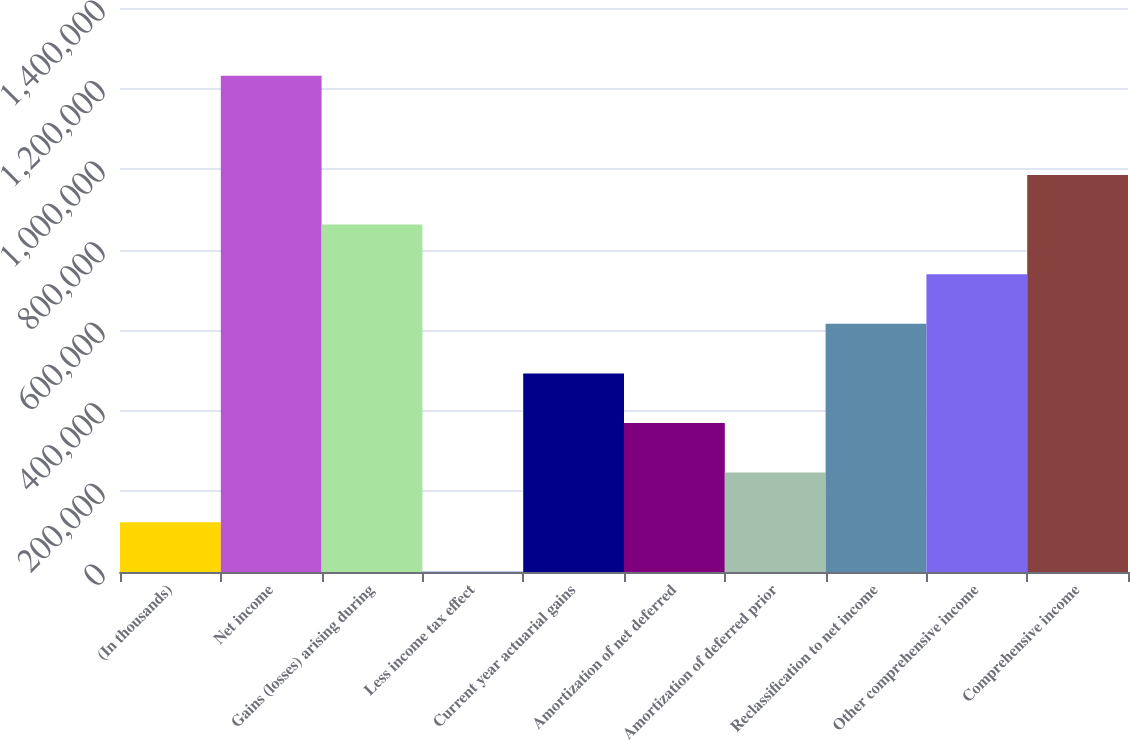Convert chart. <chart><loc_0><loc_0><loc_500><loc_500><bar_chart><fcel>(In thousands)<fcel>Net income<fcel>Gains (losses) arising during<fcel>Less income tax effect<fcel>Current year actuarial gains<fcel>Amortization of net deferred<fcel>Amortization of deferred prior<fcel>Reclassification to net income<fcel>Other comprehensive income<fcel>Comprehensive income<nl><fcel>123687<fcel>1.23159e+06<fcel>862291<fcel>586<fcel>492989<fcel>369888<fcel>246787<fcel>616090<fcel>739190<fcel>985392<nl></chart> 